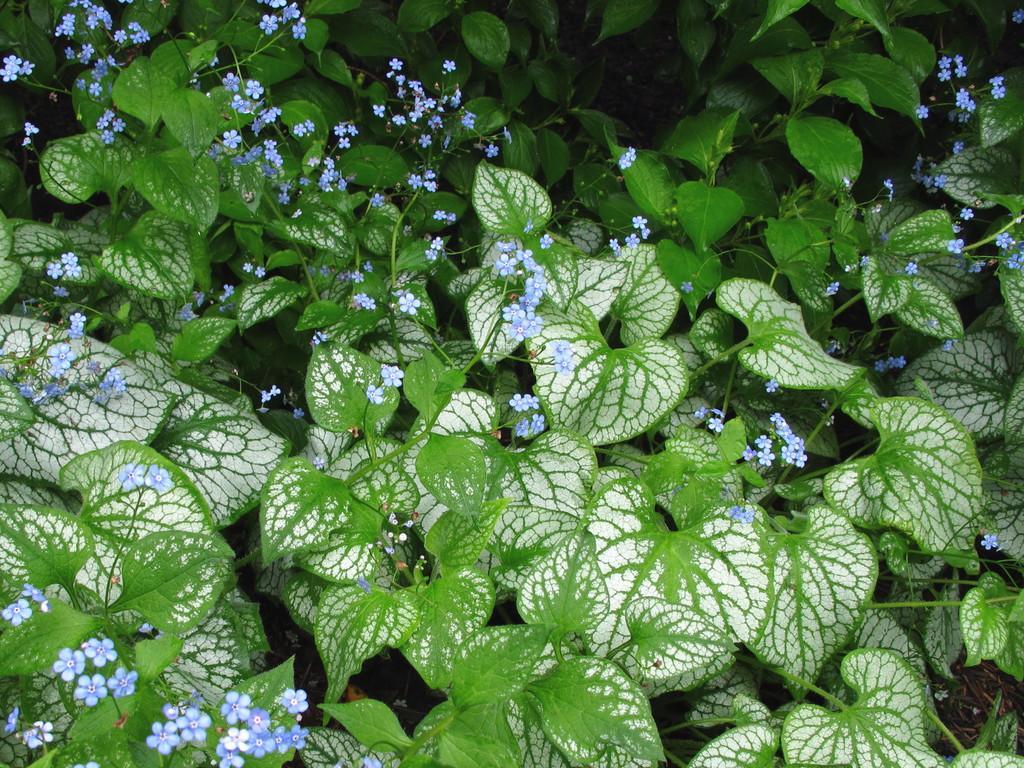In one or two sentences, can you explain what this image depicts? In this image we can see a group of plants with flowers. 